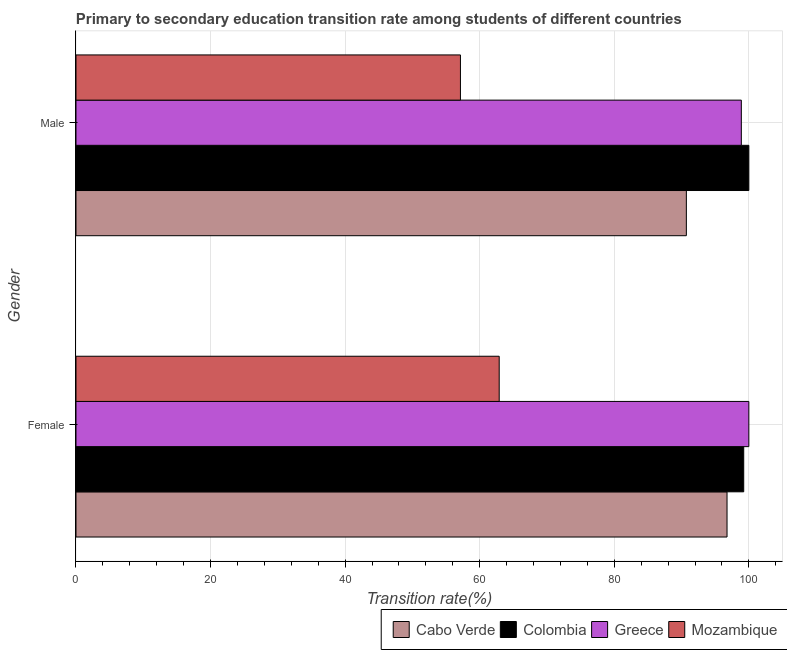How many different coloured bars are there?
Ensure brevity in your answer.  4. Are the number of bars per tick equal to the number of legend labels?
Ensure brevity in your answer.  Yes. How many bars are there on the 1st tick from the bottom?
Make the answer very short. 4. What is the transition rate among female students in Cabo Verde?
Your response must be concise. 96.76. Across all countries, what is the minimum transition rate among female students?
Provide a succinct answer. 62.9. In which country was the transition rate among female students minimum?
Your answer should be compact. Mozambique. What is the total transition rate among male students in the graph?
Ensure brevity in your answer.  346.73. What is the difference between the transition rate among male students in Mozambique and that in Colombia?
Provide a succinct answer. -42.86. What is the difference between the transition rate among male students in Colombia and the transition rate among female students in Cabo Verde?
Offer a terse response. 3.24. What is the average transition rate among female students per country?
Offer a very short reply. 89.72. What is the difference between the transition rate among male students and transition rate among female students in Colombia?
Offer a very short reply. 0.76. What is the ratio of the transition rate among male students in Mozambique to that in Colombia?
Offer a terse response. 0.57. Is the transition rate among female students in Cabo Verde less than that in Greece?
Keep it short and to the point. Yes. What does the 4th bar from the top in Female represents?
Offer a very short reply. Cabo Verde. What does the 4th bar from the bottom in Male represents?
Ensure brevity in your answer.  Mozambique. How many countries are there in the graph?
Offer a terse response. 4. What is the difference between two consecutive major ticks on the X-axis?
Offer a terse response. 20. Does the graph contain any zero values?
Your response must be concise. No. Where does the legend appear in the graph?
Provide a short and direct response. Bottom right. What is the title of the graph?
Offer a terse response. Primary to secondary education transition rate among students of different countries. Does "Hungary" appear as one of the legend labels in the graph?
Keep it short and to the point. No. What is the label or title of the X-axis?
Give a very brief answer. Transition rate(%). What is the label or title of the Y-axis?
Ensure brevity in your answer.  Gender. What is the Transition rate(%) in Cabo Verde in Female?
Give a very brief answer. 96.76. What is the Transition rate(%) in Colombia in Female?
Keep it short and to the point. 99.24. What is the Transition rate(%) of Greece in Female?
Your response must be concise. 100. What is the Transition rate(%) of Mozambique in Female?
Keep it short and to the point. 62.9. What is the Transition rate(%) of Cabo Verde in Male?
Make the answer very short. 90.71. What is the Transition rate(%) of Colombia in Male?
Offer a terse response. 100. What is the Transition rate(%) in Greece in Male?
Your answer should be compact. 98.88. What is the Transition rate(%) of Mozambique in Male?
Your answer should be very brief. 57.14. Across all Gender, what is the maximum Transition rate(%) of Cabo Verde?
Give a very brief answer. 96.76. Across all Gender, what is the maximum Transition rate(%) of Colombia?
Offer a very short reply. 100. Across all Gender, what is the maximum Transition rate(%) of Mozambique?
Offer a very short reply. 62.9. Across all Gender, what is the minimum Transition rate(%) in Cabo Verde?
Make the answer very short. 90.71. Across all Gender, what is the minimum Transition rate(%) of Colombia?
Your answer should be very brief. 99.24. Across all Gender, what is the minimum Transition rate(%) in Greece?
Provide a succinct answer. 98.88. Across all Gender, what is the minimum Transition rate(%) in Mozambique?
Ensure brevity in your answer.  57.14. What is the total Transition rate(%) of Cabo Verde in the graph?
Your answer should be compact. 187.47. What is the total Transition rate(%) in Colombia in the graph?
Provide a succinct answer. 199.24. What is the total Transition rate(%) of Greece in the graph?
Offer a very short reply. 198.88. What is the total Transition rate(%) in Mozambique in the graph?
Your answer should be compact. 120.03. What is the difference between the Transition rate(%) of Cabo Verde in Female and that in Male?
Your answer should be compact. 6.05. What is the difference between the Transition rate(%) in Colombia in Female and that in Male?
Your response must be concise. -0.76. What is the difference between the Transition rate(%) of Greece in Female and that in Male?
Provide a succinct answer. 1.12. What is the difference between the Transition rate(%) in Mozambique in Female and that in Male?
Provide a short and direct response. 5.76. What is the difference between the Transition rate(%) of Cabo Verde in Female and the Transition rate(%) of Colombia in Male?
Provide a short and direct response. -3.24. What is the difference between the Transition rate(%) of Cabo Verde in Female and the Transition rate(%) of Greece in Male?
Ensure brevity in your answer.  -2.12. What is the difference between the Transition rate(%) in Cabo Verde in Female and the Transition rate(%) in Mozambique in Male?
Offer a very short reply. 39.62. What is the difference between the Transition rate(%) of Colombia in Female and the Transition rate(%) of Greece in Male?
Make the answer very short. 0.35. What is the difference between the Transition rate(%) of Colombia in Female and the Transition rate(%) of Mozambique in Male?
Ensure brevity in your answer.  42.1. What is the difference between the Transition rate(%) in Greece in Female and the Transition rate(%) in Mozambique in Male?
Provide a succinct answer. 42.86. What is the average Transition rate(%) of Cabo Verde per Gender?
Offer a very short reply. 93.73. What is the average Transition rate(%) in Colombia per Gender?
Your answer should be very brief. 99.62. What is the average Transition rate(%) of Greece per Gender?
Your answer should be very brief. 99.44. What is the average Transition rate(%) in Mozambique per Gender?
Ensure brevity in your answer.  60.02. What is the difference between the Transition rate(%) in Cabo Verde and Transition rate(%) in Colombia in Female?
Make the answer very short. -2.48. What is the difference between the Transition rate(%) of Cabo Verde and Transition rate(%) of Greece in Female?
Your answer should be very brief. -3.24. What is the difference between the Transition rate(%) in Cabo Verde and Transition rate(%) in Mozambique in Female?
Your answer should be very brief. 33.86. What is the difference between the Transition rate(%) in Colombia and Transition rate(%) in Greece in Female?
Make the answer very short. -0.76. What is the difference between the Transition rate(%) in Colombia and Transition rate(%) in Mozambique in Female?
Your answer should be compact. 36.34. What is the difference between the Transition rate(%) of Greece and Transition rate(%) of Mozambique in Female?
Provide a succinct answer. 37.1. What is the difference between the Transition rate(%) in Cabo Verde and Transition rate(%) in Colombia in Male?
Keep it short and to the point. -9.29. What is the difference between the Transition rate(%) of Cabo Verde and Transition rate(%) of Greece in Male?
Make the answer very short. -8.17. What is the difference between the Transition rate(%) in Cabo Verde and Transition rate(%) in Mozambique in Male?
Your answer should be very brief. 33.58. What is the difference between the Transition rate(%) in Colombia and Transition rate(%) in Greece in Male?
Your answer should be compact. 1.12. What is the difference between the Transition rate(%) in Colombia and Transition rate(%) in Mozambique in Male?
Your answer should be compact. 42.86. What is the difference between the Transition rate(%) in Greece and Transition rate(%) in Mozambique in Male?
Offer a terse response. 41.75. What is the ratio of the Transition rate(%) of Cabo Verde in Female to that in Male?
Provide a short and direct response. 1.07. What is the ratio of the Transition rate(%) in Colombia in Female to that in Male?
Provide a succinct answer. 0.99. What is the ratio of the Transition rate(%) in Greece in Female to that in Male?
Provide a short and direct response. 1.01. What is the ratio of the Transition rate(%) in Mozambique in Female to that in Male?
Provide a short and direct response. 1.1. What is the difference between the highest and the second highest Transition rate(%) of Cabo Verde?
Offer a terse response. 6.05. What is the difference between the highest and the second highest Transition rate(%) of Colombia?
Your answer should be very brief. 0.76. What is the difference between the highest and the second highest Transition rate(%) of Greece?
Ensure brevity in your answer.  1.12. What is the difference between the highest and the second highest Transition rate(%) of Mozambique?
Ensure brevity in your answer.  5.76. What is the difference between the highest and the lowest Transition rate(%) in Cabo Verde?
Provide a short and direct response. 6.05. What is the difference between the highest and the lowest Transition rate(%) of Colombia?
Provide a succinct answer. 0.76. What is the difference between the highest and the lowest Transition rate(%) in Greece?
Your answer should be compact. 1.12. What is the difference between the highest and the lowest Transition rate(%) in Mozambique?
Keep it short and to the point. 5.76. 